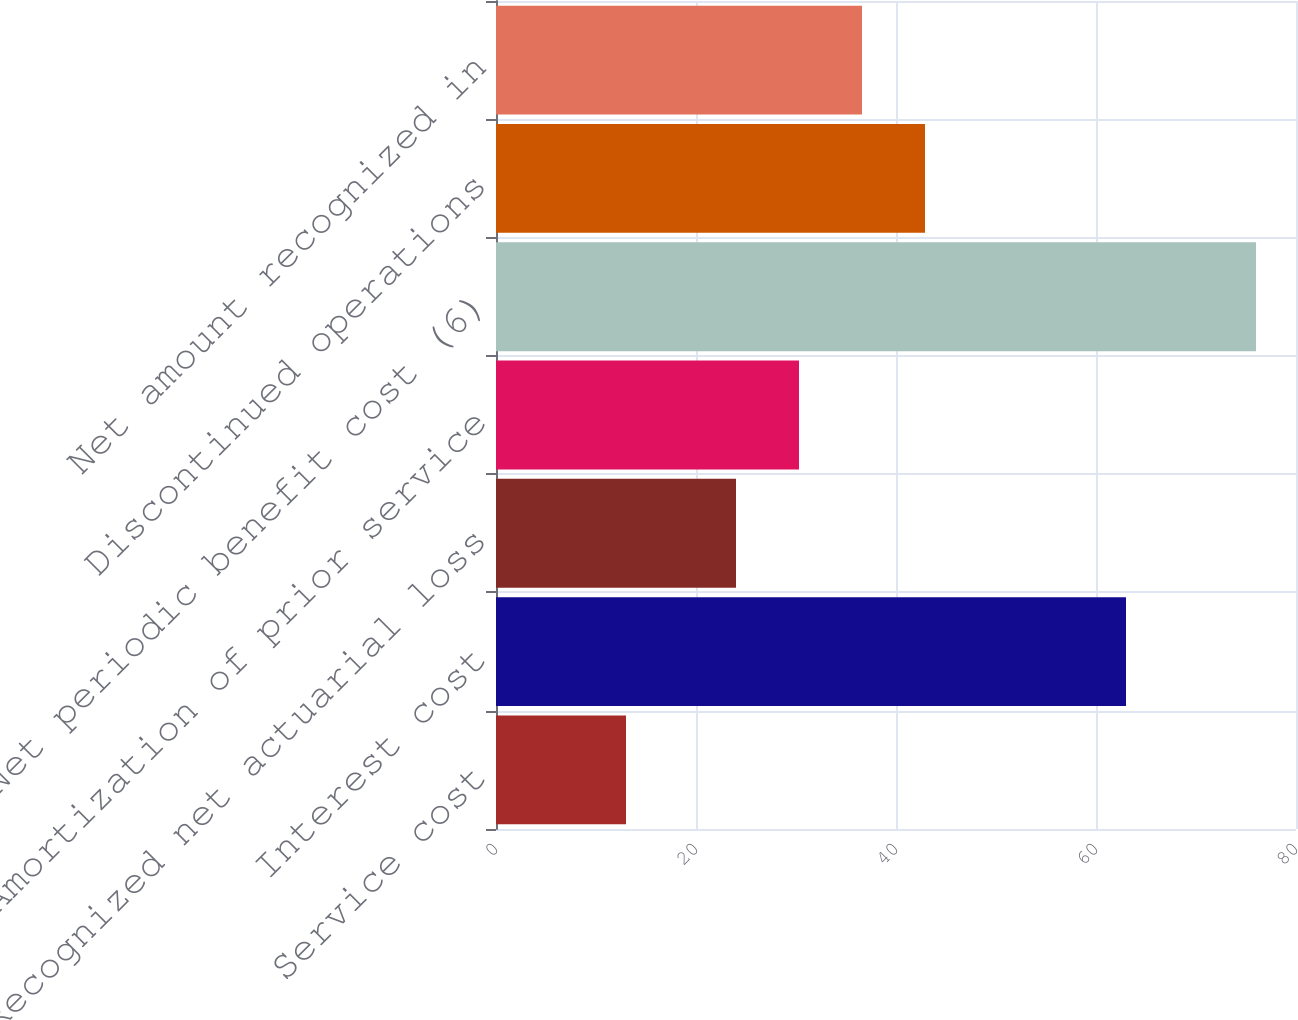<chart> <loc_0><loc_0><loc_500><loc_500><bar_chart><fcel>Service cost<fcel>Interest cost<fcel>Recognized net actuarial loss<fcel>Amortization of prior service<fcel>Net periodic benefit cost (6)<fcel>Discontinued operations<fcel>Net amount recognized in<nl><fcel>13<fcel>63<fcel>24<fcel>30.3<fcel>76<fcel>42.9<fcel>36.6<nl></chart> 